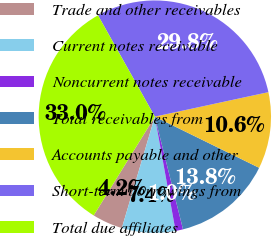Convert chart to OTSL. <chart><loc_0><loc_0><loc_500><loc_500><pie_chart><fcel>Trade and other receivables<fcel>Current notes receivable<fcel>Noncurrent notes receivable<fcel>Total receivables from<fcel>Accounts payable and other<fcel>Short-term borrowings from<fcel>Total due affiliates<nl><fcel>4.24%<fcel>7.44%<fcel>1.04%<fcel>13.84%<fcel>10.64%<fcel>29.76%<fcel>33.04%<nl></chart> 